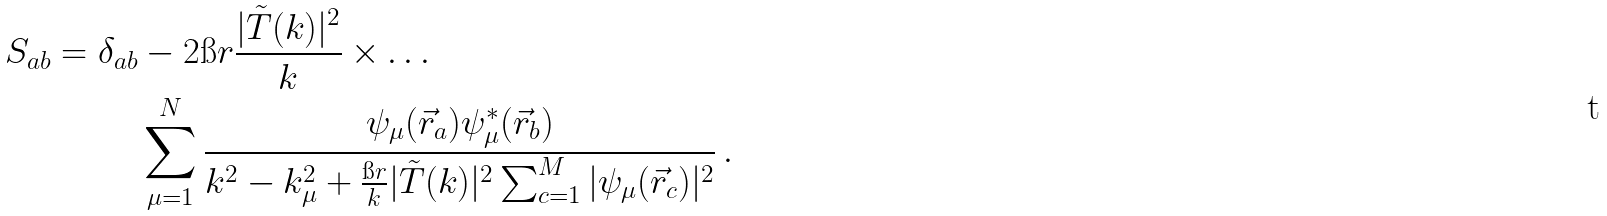Convert formula to latex. <formula><loc_0><loc_0><loc_500><loc_500>S _ { a b } = \delta _ { a b } & - 2 \i r \frac { | \tilde { T } ( k ) | ^ { 2 } } { k } \times \dots \\ & \sum _ { \mu = 1 } ^ { N } \frac { \psi _ { \mu } ( \vec { r } _ { a } ) \psi _ { \mu } ^ { * } ( \vec { r } _ { b } ) } { k ^ { 2 } - k _ { \mu } ^ { 2 } + \frac { \i r } { k } | \tilde { T } ( k ) | ^ { 2 } \sum _ { c = 1 } ^ { M } | \psi _ { \mu } ( \vec { r } _ { c } ) | ^ { 2 } } \, .</formula> 